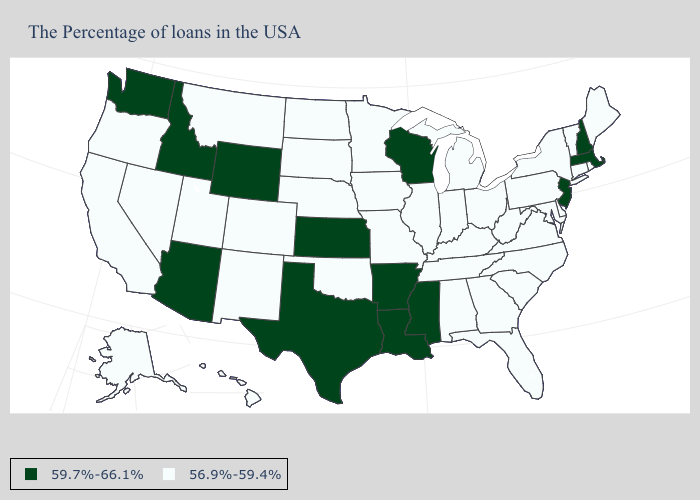Which states have the lowest value in the USA?
Quick response, please. Maine, Rhode Island, Vermont, Connecticut, New York, Delaware, Maryland, Pennsylvania, Virginia, North Carolina, South Carolina, West Virginia, Ohio, Florida, Georgia, Michigan, Kentucky, Indiana, Alabama, Tennessee, Illinois, Missouri, Minnesota, Iowa, Nebraska, Oklahoma, South Dakota, North Dakota, Colorado, New Mexico, Utah, Montana, Nevada, California, Oregon, Alaska, Hawaii. How many symbols are there in the legend?
Give a very brief answer. 2. What is the lowest value in the Northeast?
Keep it brief. 56.9%-59.4%. Name the states that have a value in the range 56.9%-59.4%?
Keep it brief. Maine, Rhode Island, Vermont, Connecticut, New York, Delaware, Maryland, Pennsylvania, Virginia, North Carolina, South Carolina, West Virginia, Ohio, Florida, Georgia, Michigan, Kentucky, Indiana, Alabama, Tennessee, Illinois, Missouri, Minnesota, Iowa, Nebraska, Oklahoma, South Dakota, North Dakota, Colorado, New Mexico, Utah, Montana, Nevada, California, Oregon, Alaska, Hawaii. Name the states that have a value in the range 59.7%-66.1%?
Quick response, please. Massachusetts, New Hampshire, New Jersey, Wisconsin, Mississippi, Louisiana, Arkansas, Kansas, Texas, Wyoming, Arizona, Idaho, Washington. Among the states that border Rhode Island , does Massachusetts have the lowest value?
Short answer required. No. Does Idaho have the same value as New Hampshire?
Answer briefly. Yes. Does Nebraska have the same value as South Carolina?
Answer briefly. Yes. What is the value of Washington?
Concise answer only. 59.7%-66.1%. What is the value of Rhode Island?
Quick response, please. 56.9%-59.4%. What is the lowest value in states that border Maryland?
Short answer required. 56.9%-59.4%. What is the lowest value in states that border Colorado?
Quick response, please. 56.9%-59.4%. What is the value of Rhode Island?
Concise answer only. 56.9%-59.4%. Name the states that have a value in the range 59.7%-66.1%?
Answer briefly. Massachusetts, New Hampshire, New Jersey, Wisconsin, Mississippi, Louisiana, Arkansas, Kansas, Texas, Wyoming, Arizona, Idaho, Washington. What is the highest value in the USA?
Concise answer only. 59.7%-66.1%. 